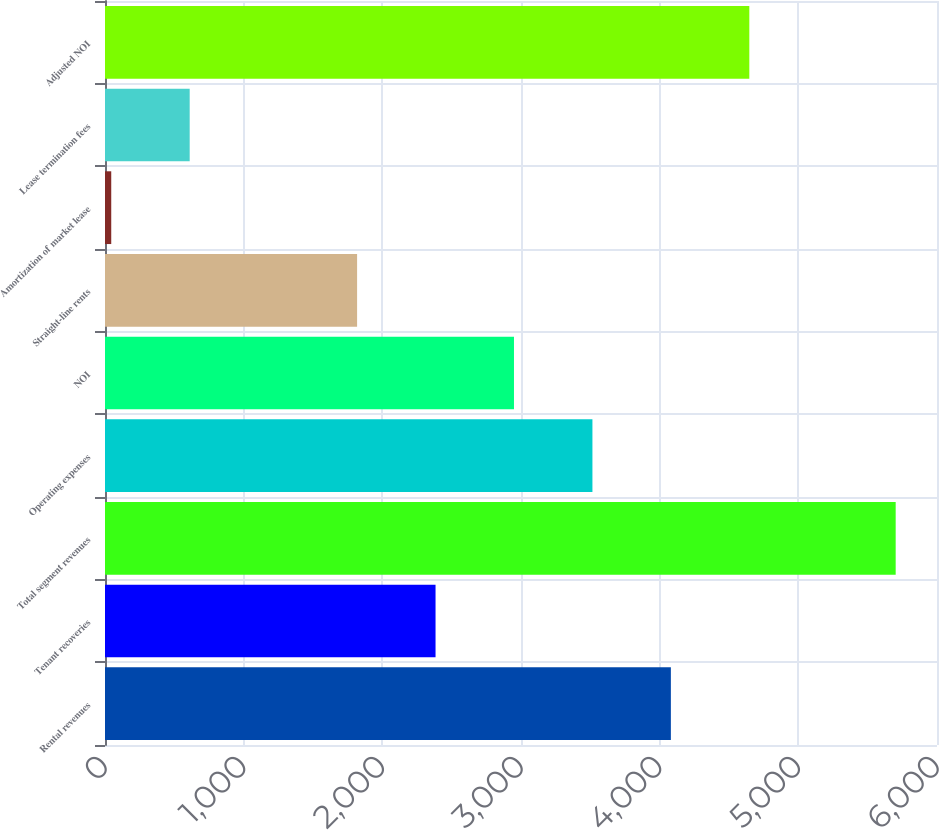Convert chart. <chart><loc_0><loc_0><loc_500><loc_500><bar_chart><fcel>Rental revenues<fcel>Tenant recoveries<fcel>Total segment revenues<fcel>Operating expenses<fcel>NOI<fcel>Straight-line rents<fcel>Amortization of market lease<fcel>Lease termination fees<fcel>Adjusted NOI<nl><fcel>4080.8<fcel>2383.7<fcel>5702<fcel>3515.1<fcel>2949.4<fcel>1818<fcel>45<fcel>610.7<fcel>4646.5<nl></chart> 